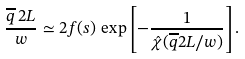<formula> <loc_0><loc_0><loc_500><loc_500>\frac { \overline { q } \, 2 L } { w } \simeq 2 f ( s ) \, \exp \left [ - \frac { 1 } { \hat { \chi } ( \overline { q } 2 L / w ) } \right ] .</formula> 